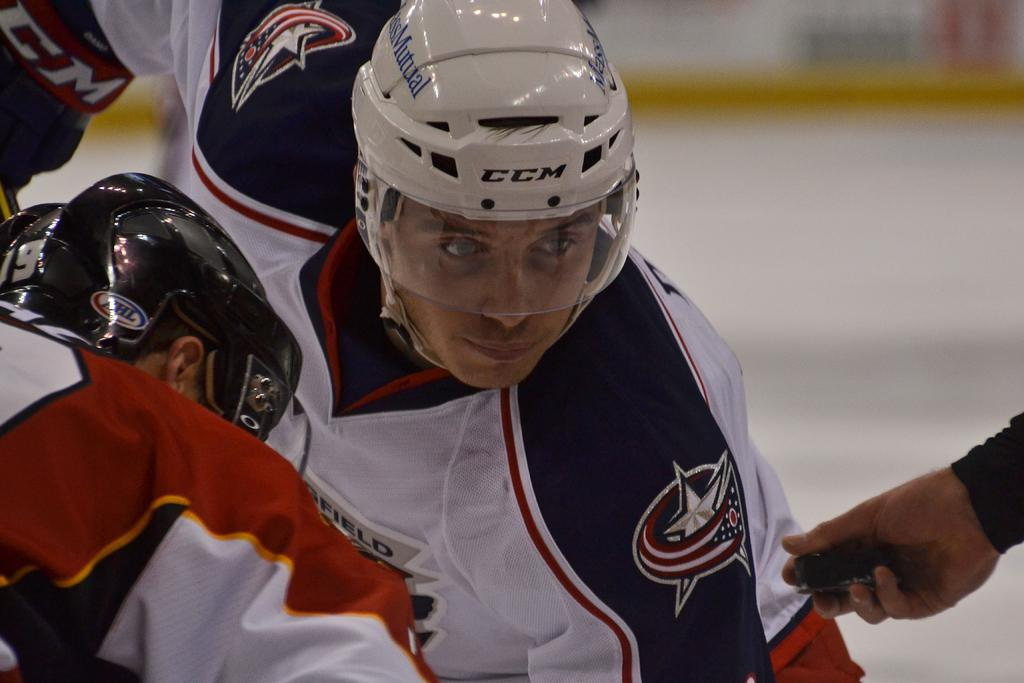How many people are in the image? There are two persons in the image. What are the persons wearing on their heads? The persons are wearing helmets. Can you describe the hand of a person in the image? There is a hand of a person holding an object in the image. What can be observed about the background of the image? The background of the image is blurred. What type of waves can be seen in the image? There are no waves present in the image. Can you describe the lip of the person in the image? There is no lip visible in the image, as both persons are wearing helmets that cover their faces. 